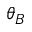<formula> <loc_0><loc_0><loc_500><loc_500>\theta _ { B }</formula> 